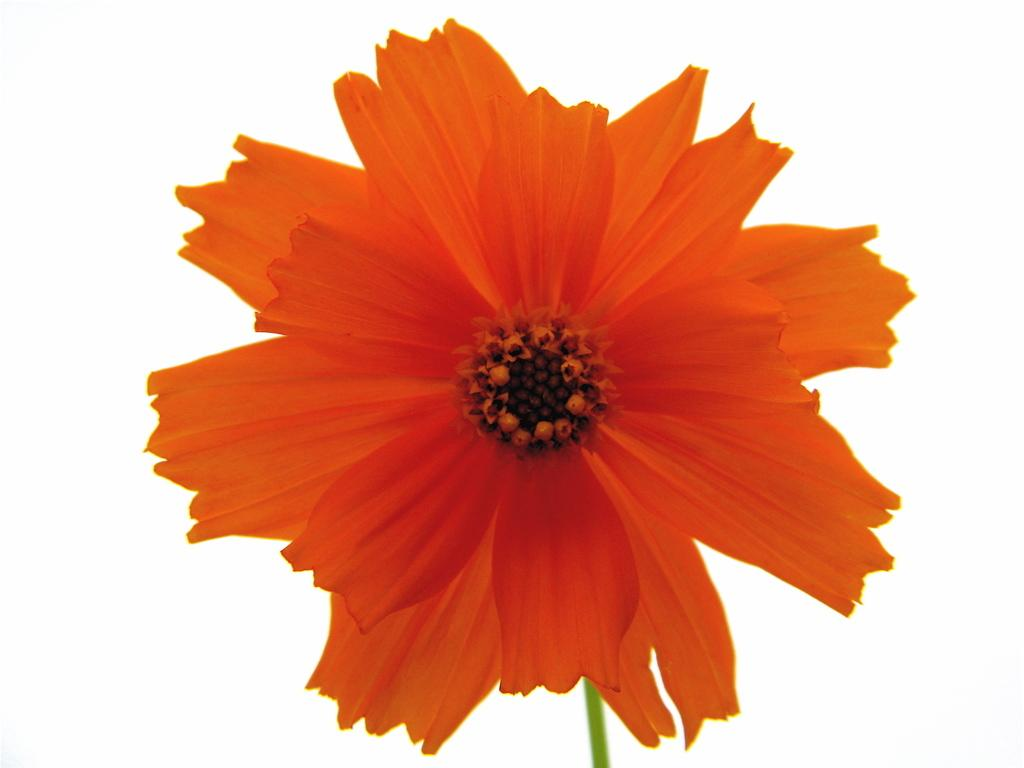What type of flower is present in the image? There is an orange color flower in the image. What color is the background of the image? The background of the image is white in color. What type of surprise can be seen in the image? There is no surprise present in the image; it features an orange color flower against a white background. Is the flower in the image hot to the touch? The image is a static representation and does not convey temperature information, so it cannot be determined if the flower is hot to the touch. 